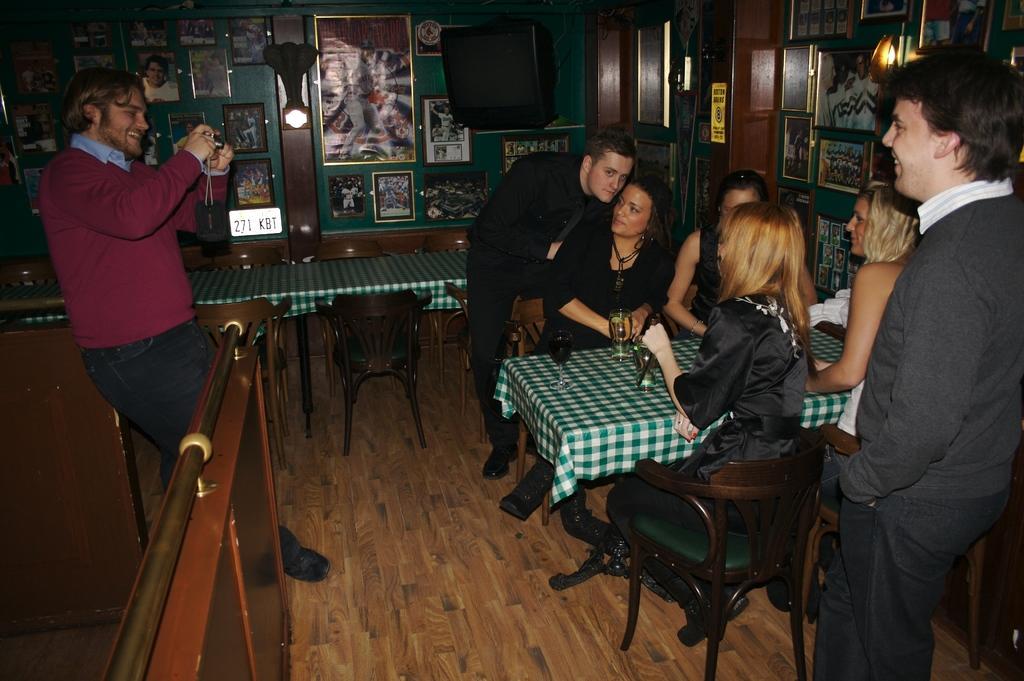Could you give a brief overview of what you see in this image? There are four women sitting on the chairs and two men standing. This is the table covered with a cloth. These are the wine glasses on the table. Here is another man standing and holding the camera. At background I can see photo frame and posts attached to the wall. This is the television. This looks like a wooden door. I can see another table and chairs. 